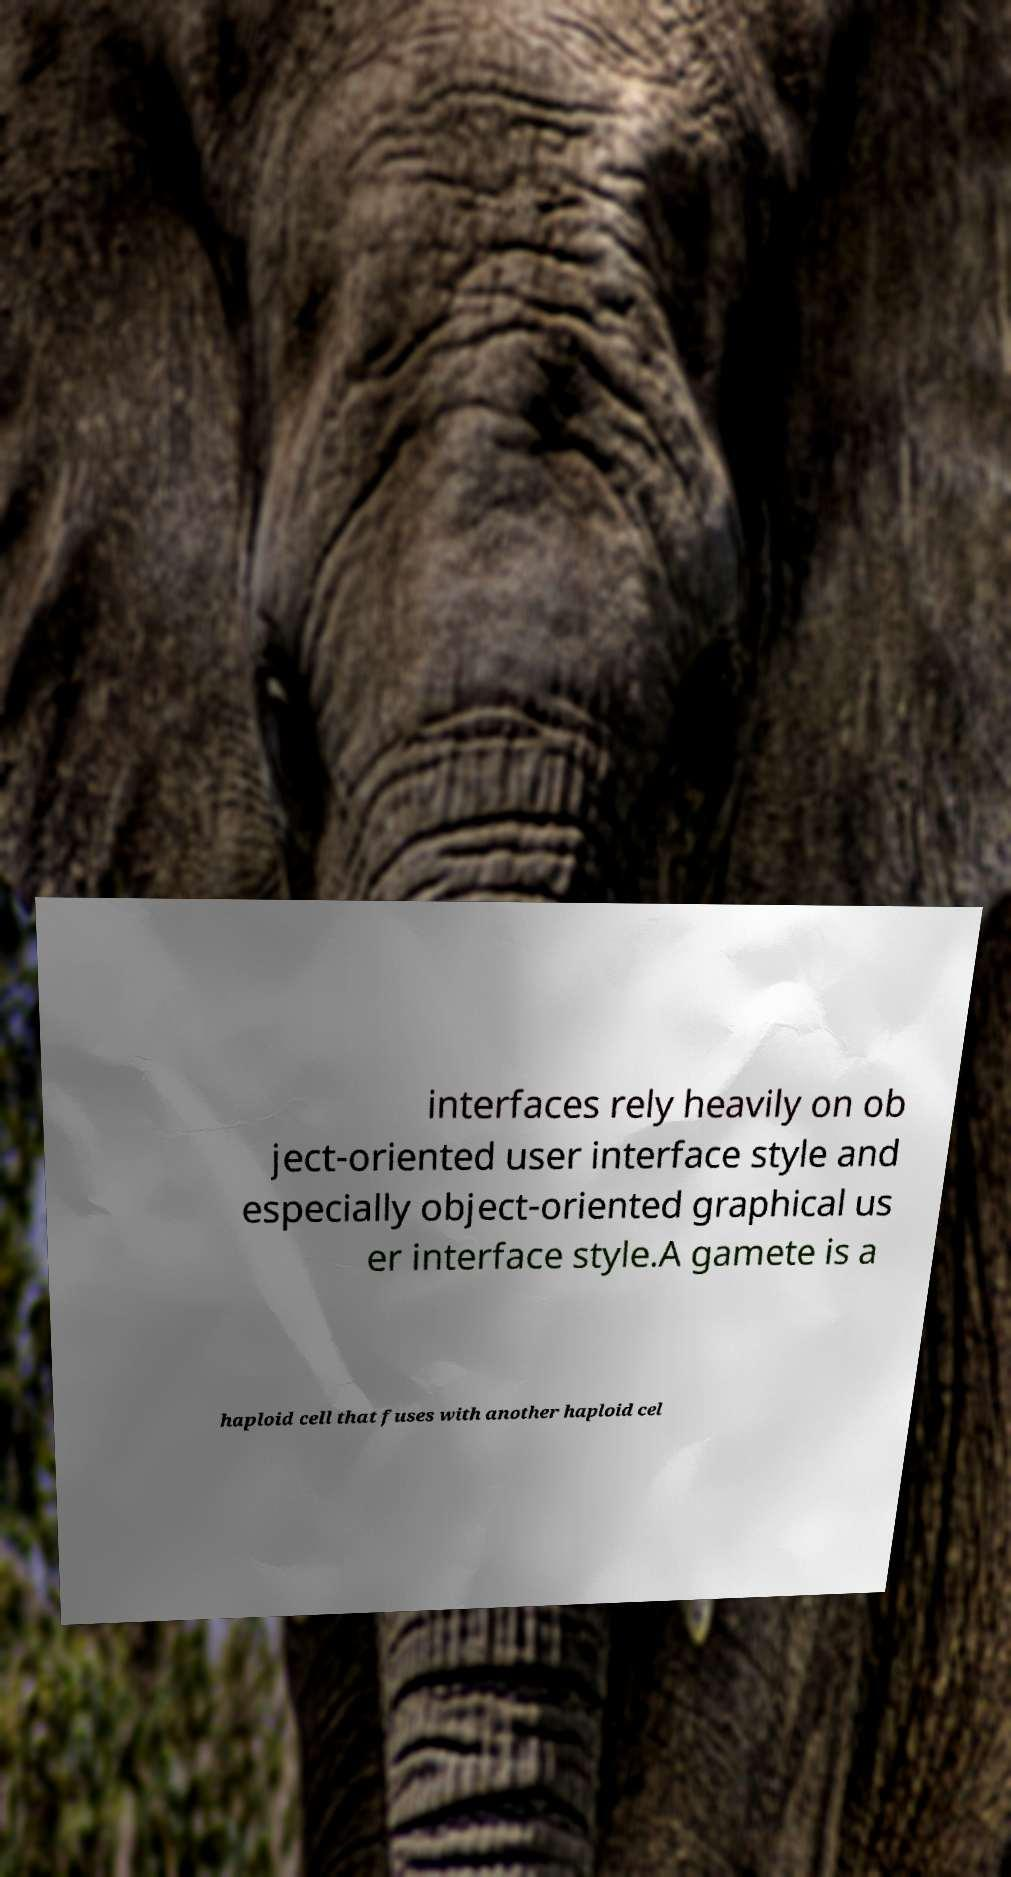I need the written content from this picture converted into text. Can you do that? interfaces rely heavily on ob ject-oriented user interface style and especially object-oriented graphical us er interface style.A gamete is a haploid cell that fuses with another haploid cel 